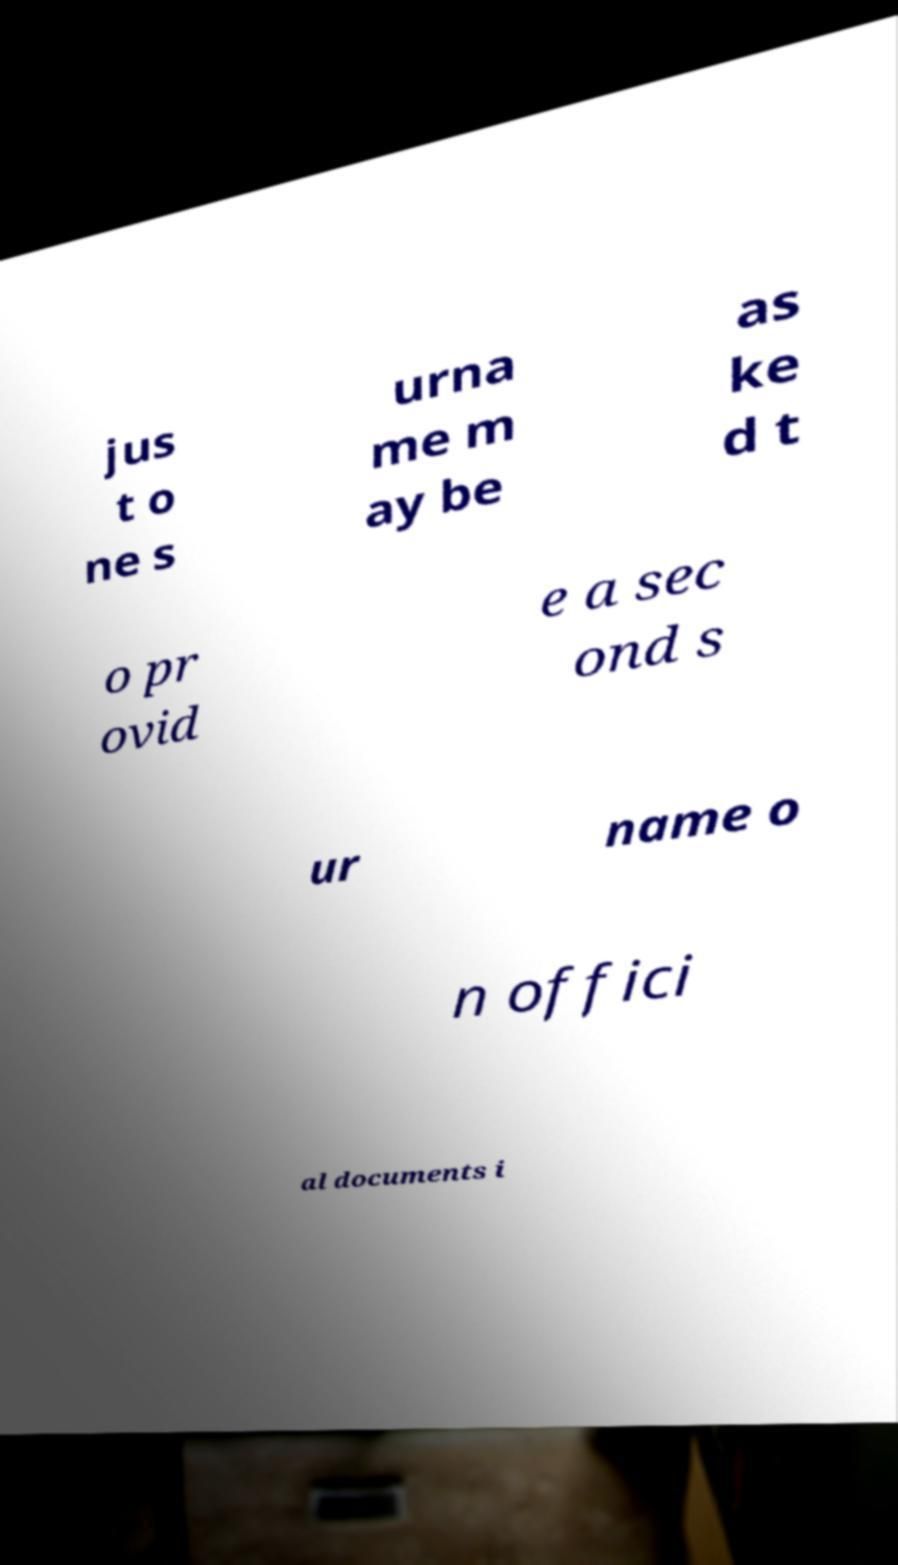For documentation purposes, I need the text within this image transcribed. Could you provide that? jus t o ne s urna me m ay be as ke d t o pr ovid e a sec ond s ur name o n offici al documents i 